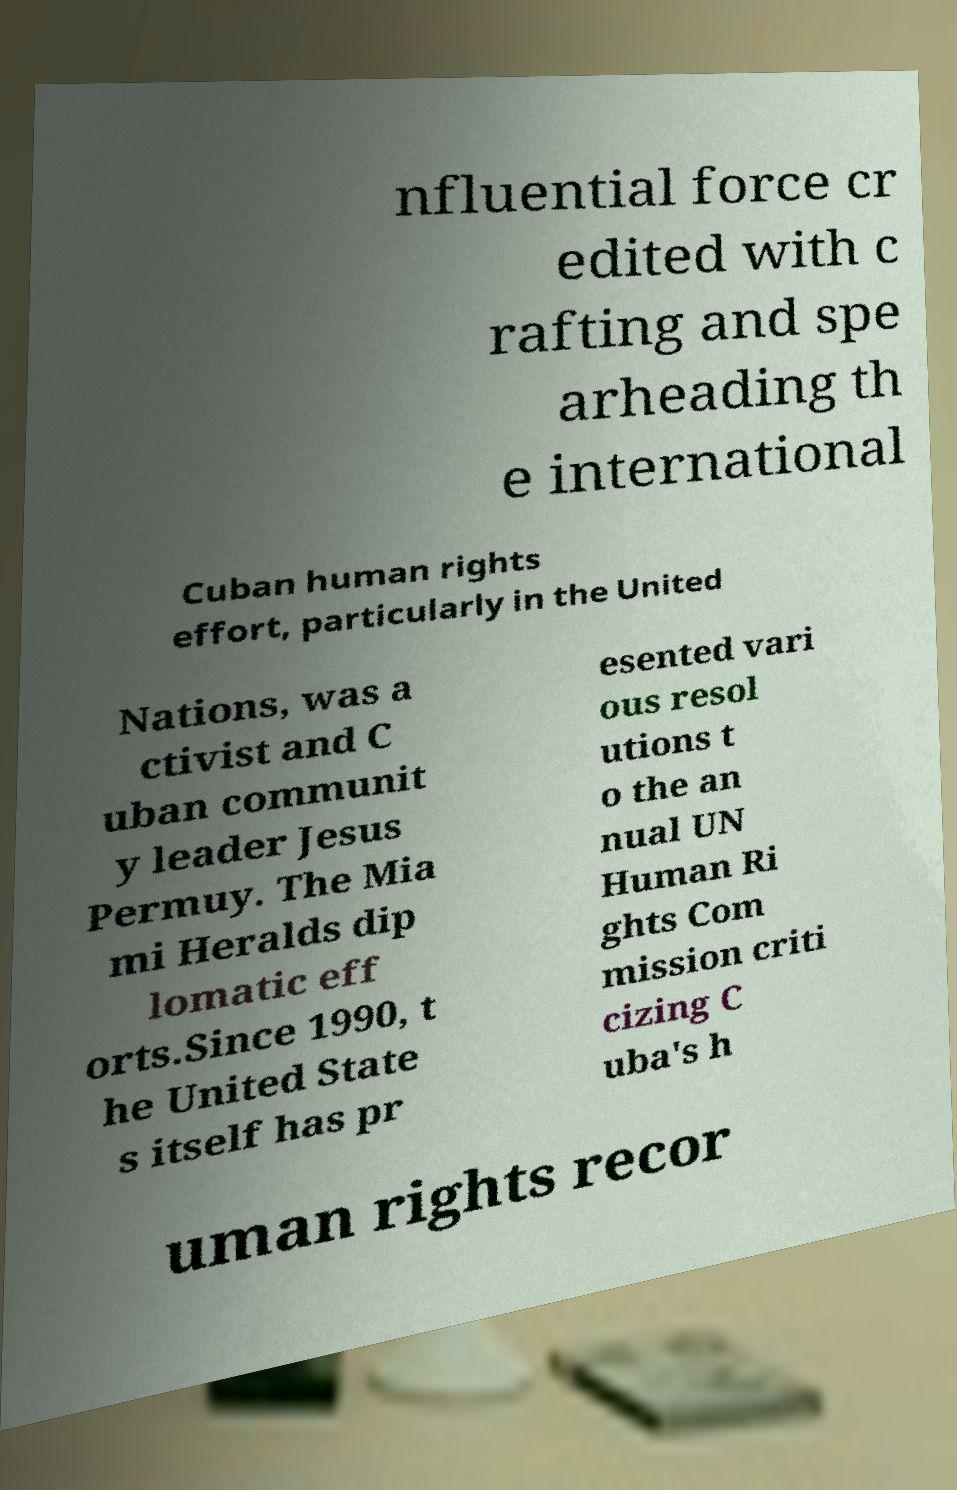Can you accurately transcribe the text from the provided image for me? nfluential force cr edited with c rafting and spe arheading th e international Cuban human rights effort, particularly in the United Nations, was a ctivist and C uban communit y leader Jesus Permuy. The Mia mi Heralds dip lomatic eff orts.Since 1990, t he United State s itself has pr esented vari ous resol utions t o the an nual UN Human Ri ghts Com mission criti cizing C uba's h uman rights recor 